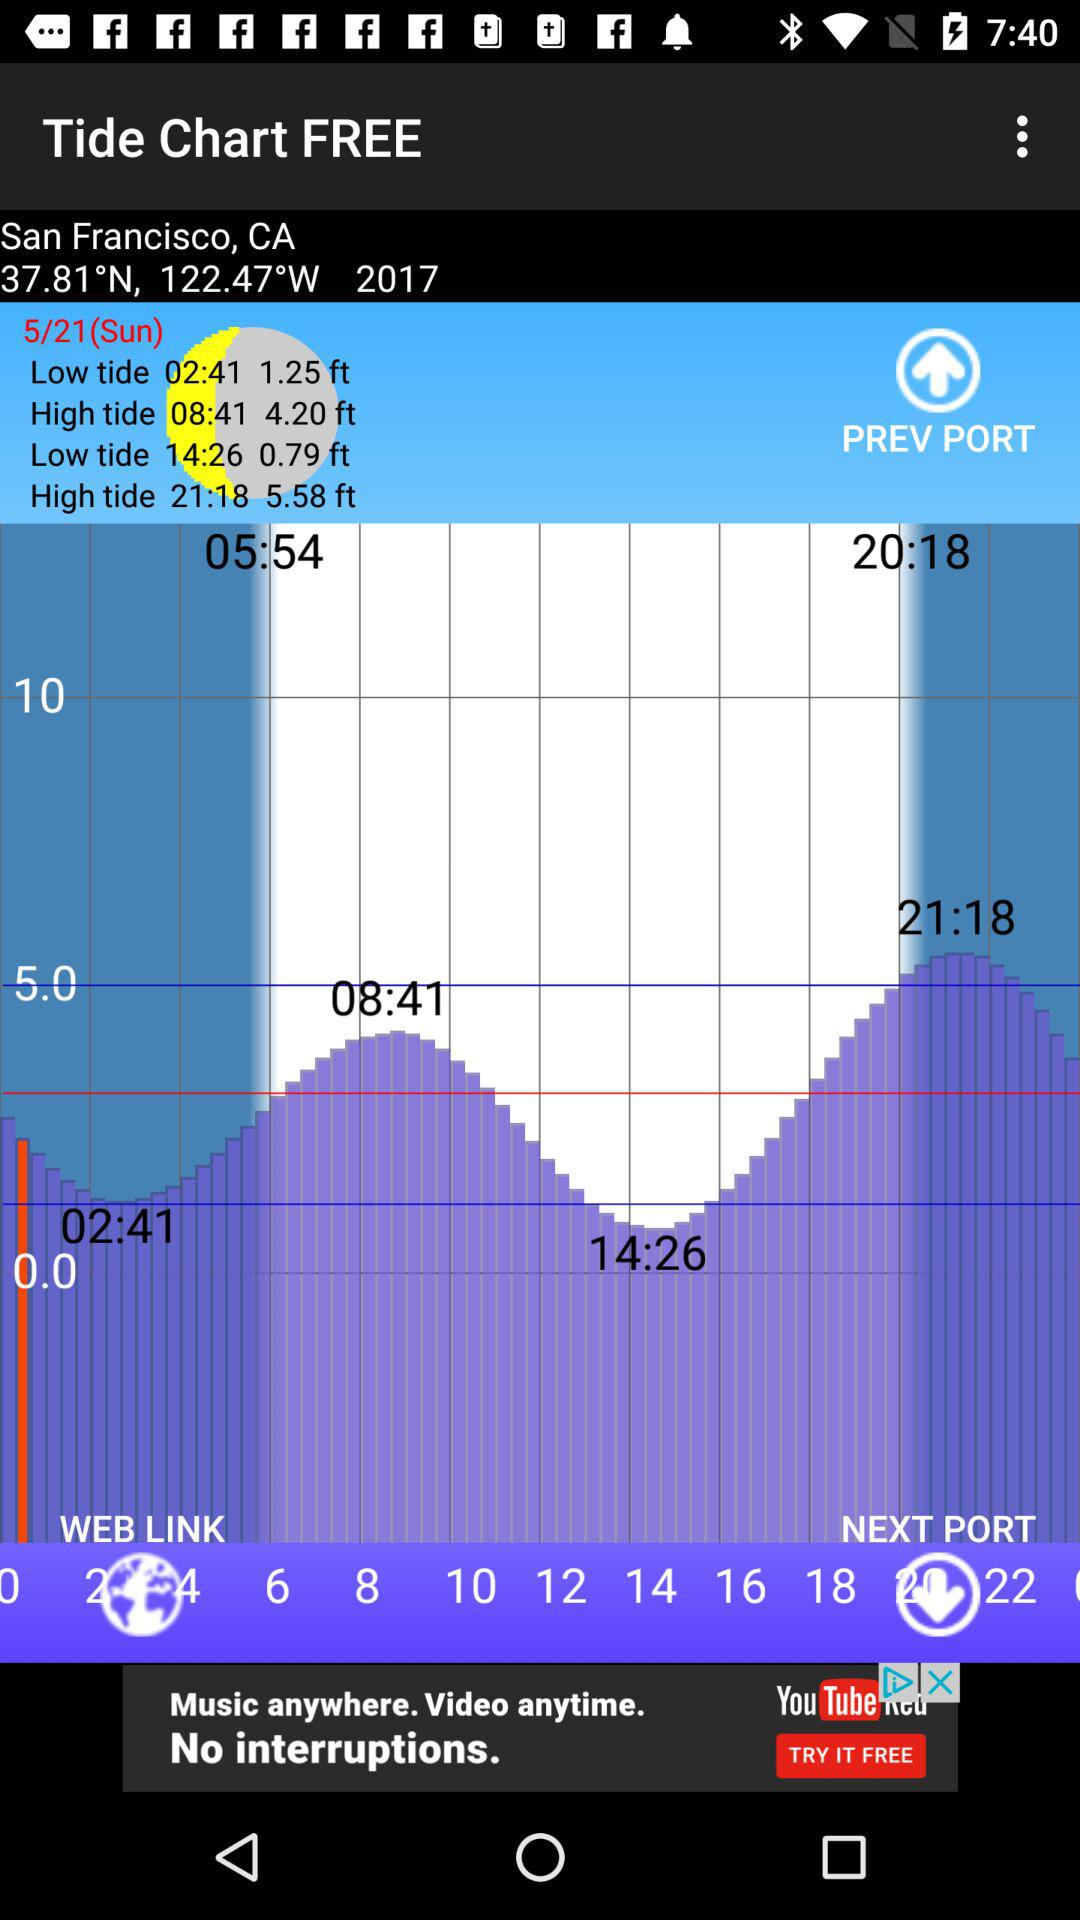What is the year displayed in the "Tide Chart FREE"? The displayed year is 2017. 